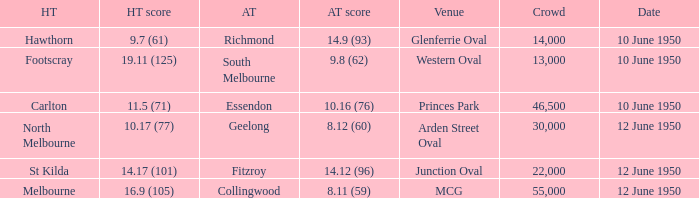Who was the away team when the VFL played at MCG? Collingwood. 